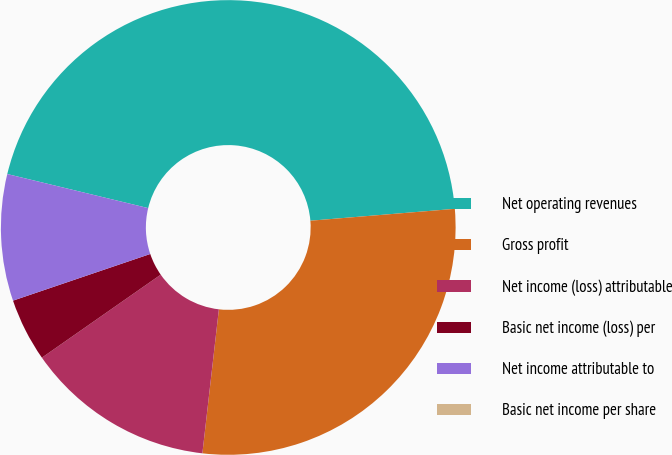Convert chart. <chart><loc_0><loc_0><loc_500><loc_500><pie_chart><fcel>Net operating revenues<fcel>Gross profit<fcel>Net income (loss) attributable<fcel>Basic net income (loss) per<fcel>Net income attributable to<fcel>Basic net income per share<nl><fcel>44.92%<fcel>28.12%<fcel>13.48%<fcel>4.49%<fcel>8.99%<fcel>0.0%<nl></chart> 